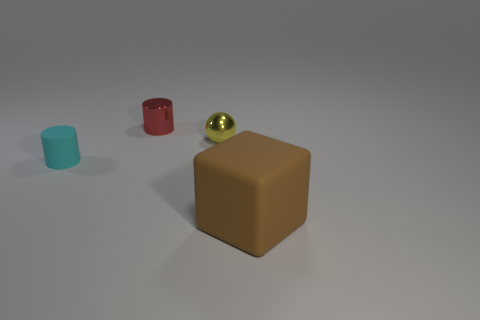Add 1 tiny red matte cylinders. How many objects exist? 5 Subtract 1 balls. How many balls are left? 0 Subtract all spheres. How many objects are left? 3 Subtract all red spheres. Subtract all green cylinders. How many spheres are left? 1 Subtract all yellow shiny things. Subtract all small green metallic cylinders. How many objects are left? 3 Add 2 small cyan rubber things. How many small cyan rubber things are left? 3 Add 2 brown blocks. How many brown blocks exist? 3 Subtract 0 brown spheres. How many objects are left? 4 